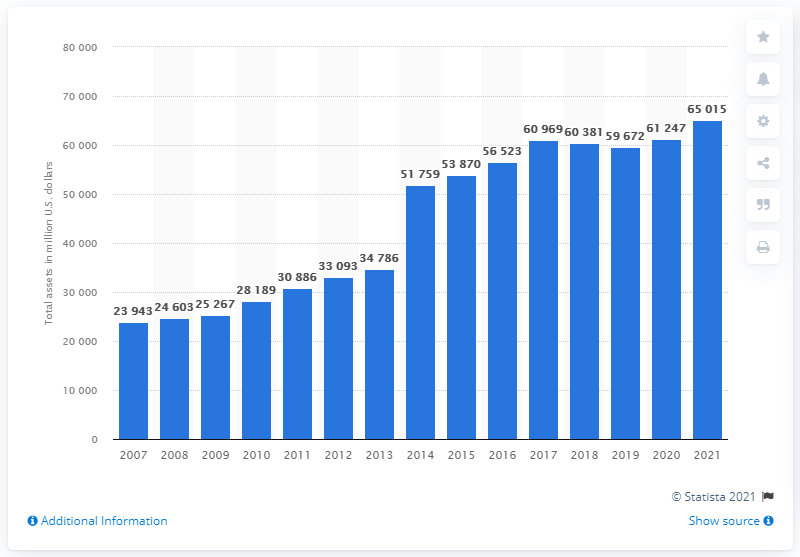Draw attention to some important aspects in this diagram. In the fiscal year 2021, the total assets of McKesson Corporation were approximately 650,150. 